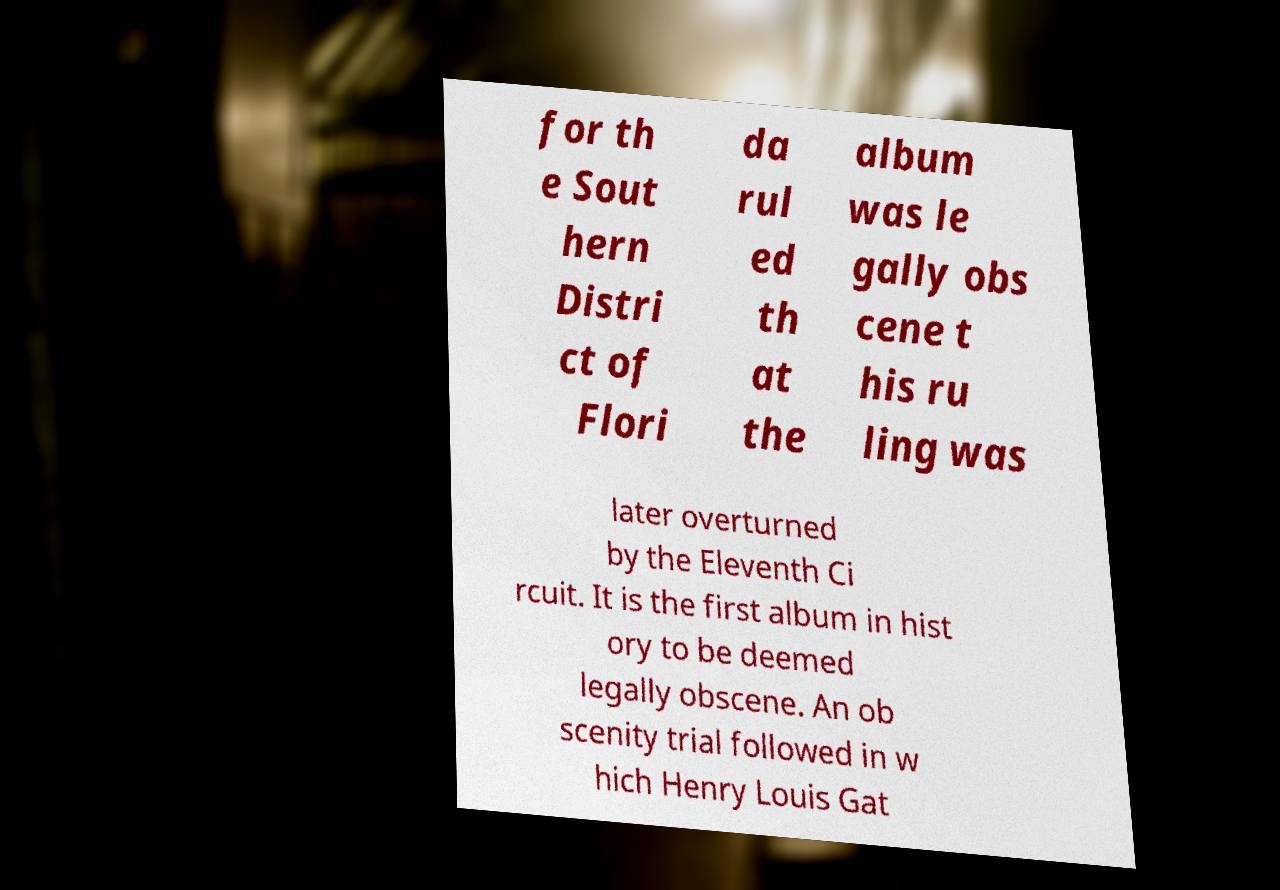Please identify and transcribe the text found in this image. for th e Sout hern Distri ct of Flori da rul ed th at the album was le gally obs cene t his ru ling was later overturned by the Eleventh Ci rcuit. It is the first album in hist ory to be deemed legally obscene. An ob scenity trial followed in w hich Henry Louis Gat 